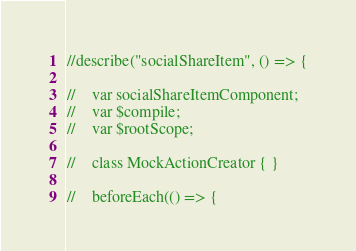Convert code to text. <code><loc_0><loc_0><loc_500><loc_500><_TypeScript_>//describe("socialShareItem", () => {

//    var socialShareItemComponent;
//    var $compile;
//    var $rootScope;

//    class MockActionCreator { }

//    beforeEach(() => {</code> 